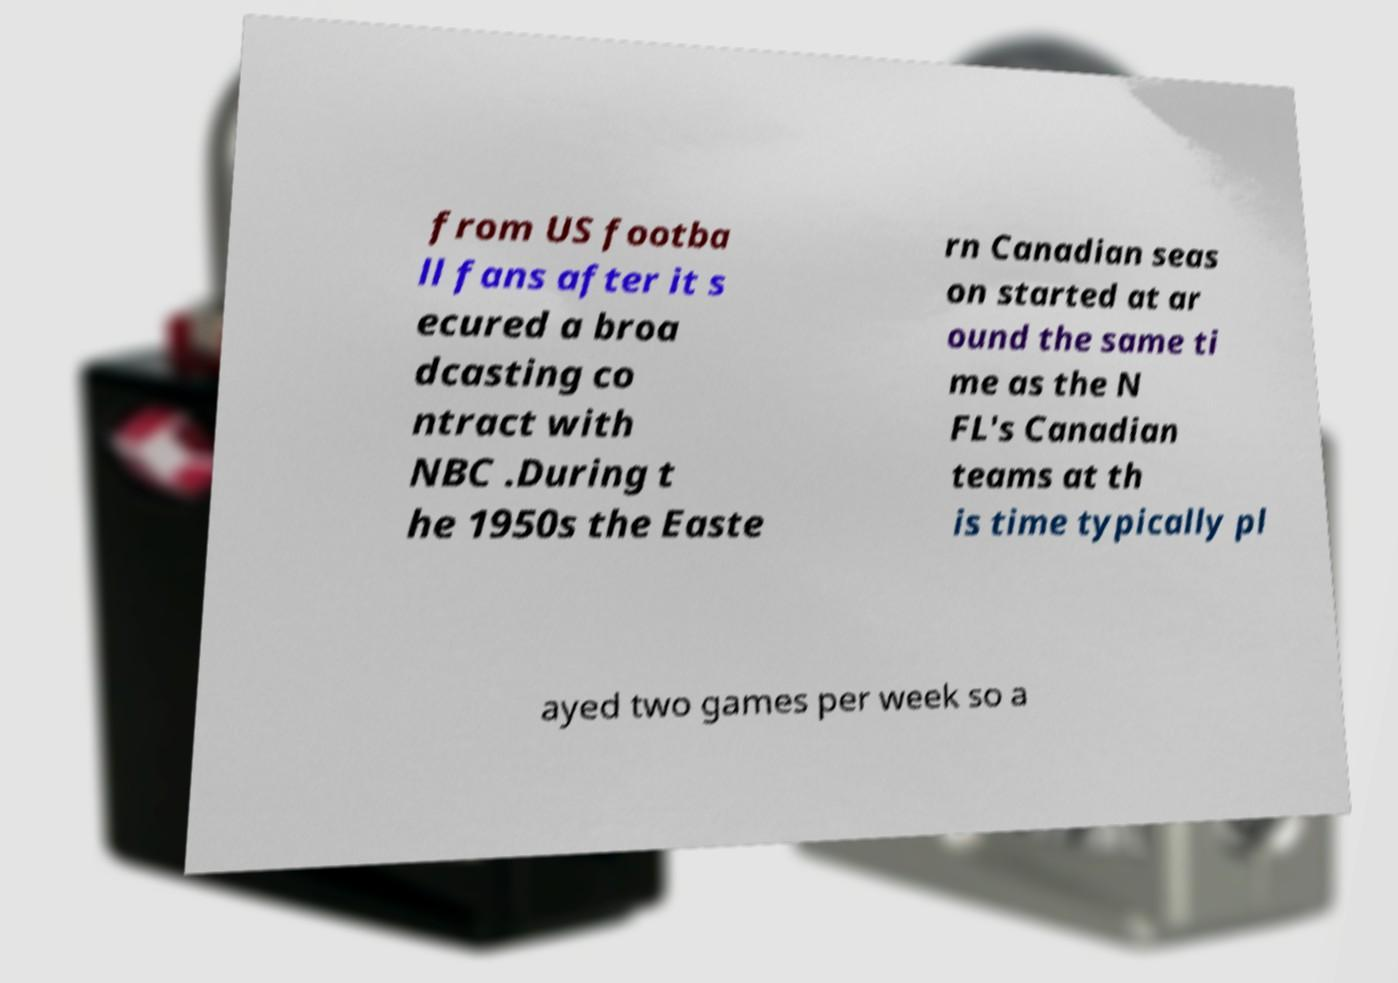Could you assist in decoding the text presented in this image and type it out clearly? from US footba ll fans after it s ecured a broa dcasting co ntract with NBC .During t he 1950s the Easte rn Canadian seas on started at ar ound the same ti me as the N FL's Canadian teams at th is time typically pl ayed two games per week so a 